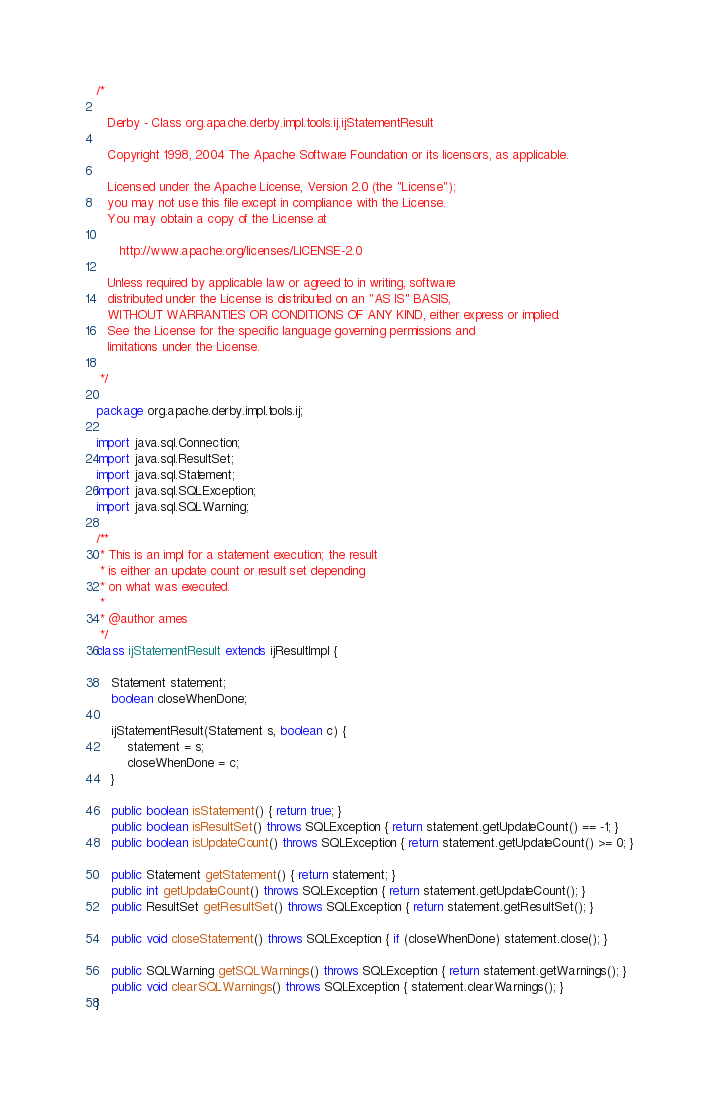Convert code to text. <code><loc_0><loc_0><loc_500><loc_500><_Java_>/*

   Derby - Class org.apache.derby.impl.tools.ij.ijStatementResult

   Copyright 1998, 2004 The Apache Software Foundation or its licensors, as applicable.

   Licensed under the Apache License, Version 2.0 (the "License");
   you may not use this file except in compliance with the License.
   You may obtain a copy of the License at

      http://www.apache.org/licenses/LICENSE-2.0

   Unless required by applicable law or agreed to in writing, software
   distributed under the License is distributed on an "AS IS" BASIS,
   WITHOUT WARRANTIES OR CONDITIONS OF ANY KIND, either express or implied.
   See the License for the specific language governing permissions and
   limitations under the License.

 */

package org.apache.derby.impl.tools.ij;

import java.sql.Connection;
import java.sql.ResultSet;
import java.sql.Statement;
import java.sql.SQLException;
import java.sql.SQLWarning;

/**
 * This is an impl for a statement execution; the result
 * is either an update count or result set depending
 * on what was executed.
 *
 * @author ames
 */
class ijStatementResult extends ijResultImpl {

	Statement statement;
	boolean closeWhenDone;

	ijStatementResult(Statement s, boolean c) {
		statement = s;
		closeWhenDone = c;
	}

	public boolean isStatement() { return true; }
	public boolean isResultSet() throws SQLException { return statement.getUpdateCount() == -1; }
	public boolean isUpdateCount() throws SQLException { return statement.getUpdateCount() >= 0; }

	public Statement getStatement() { return statement; }
	public int getUpdateCount() throws SQLException { return statement.getUpdateCount(); }
	public ResultSet getResultSet() throws SQLException { return statement.getResultSet(); }

	public void closeStatement() throws SQLException { if (closeWhenDone) statement.close(); }

	public SQLWarning getSQLWarnings() throws SQLException { return statement.getWarnings(); }
	public void clearSQLWarnings() throws SQLException { statement.clearWarnings(); }
}
</code> 